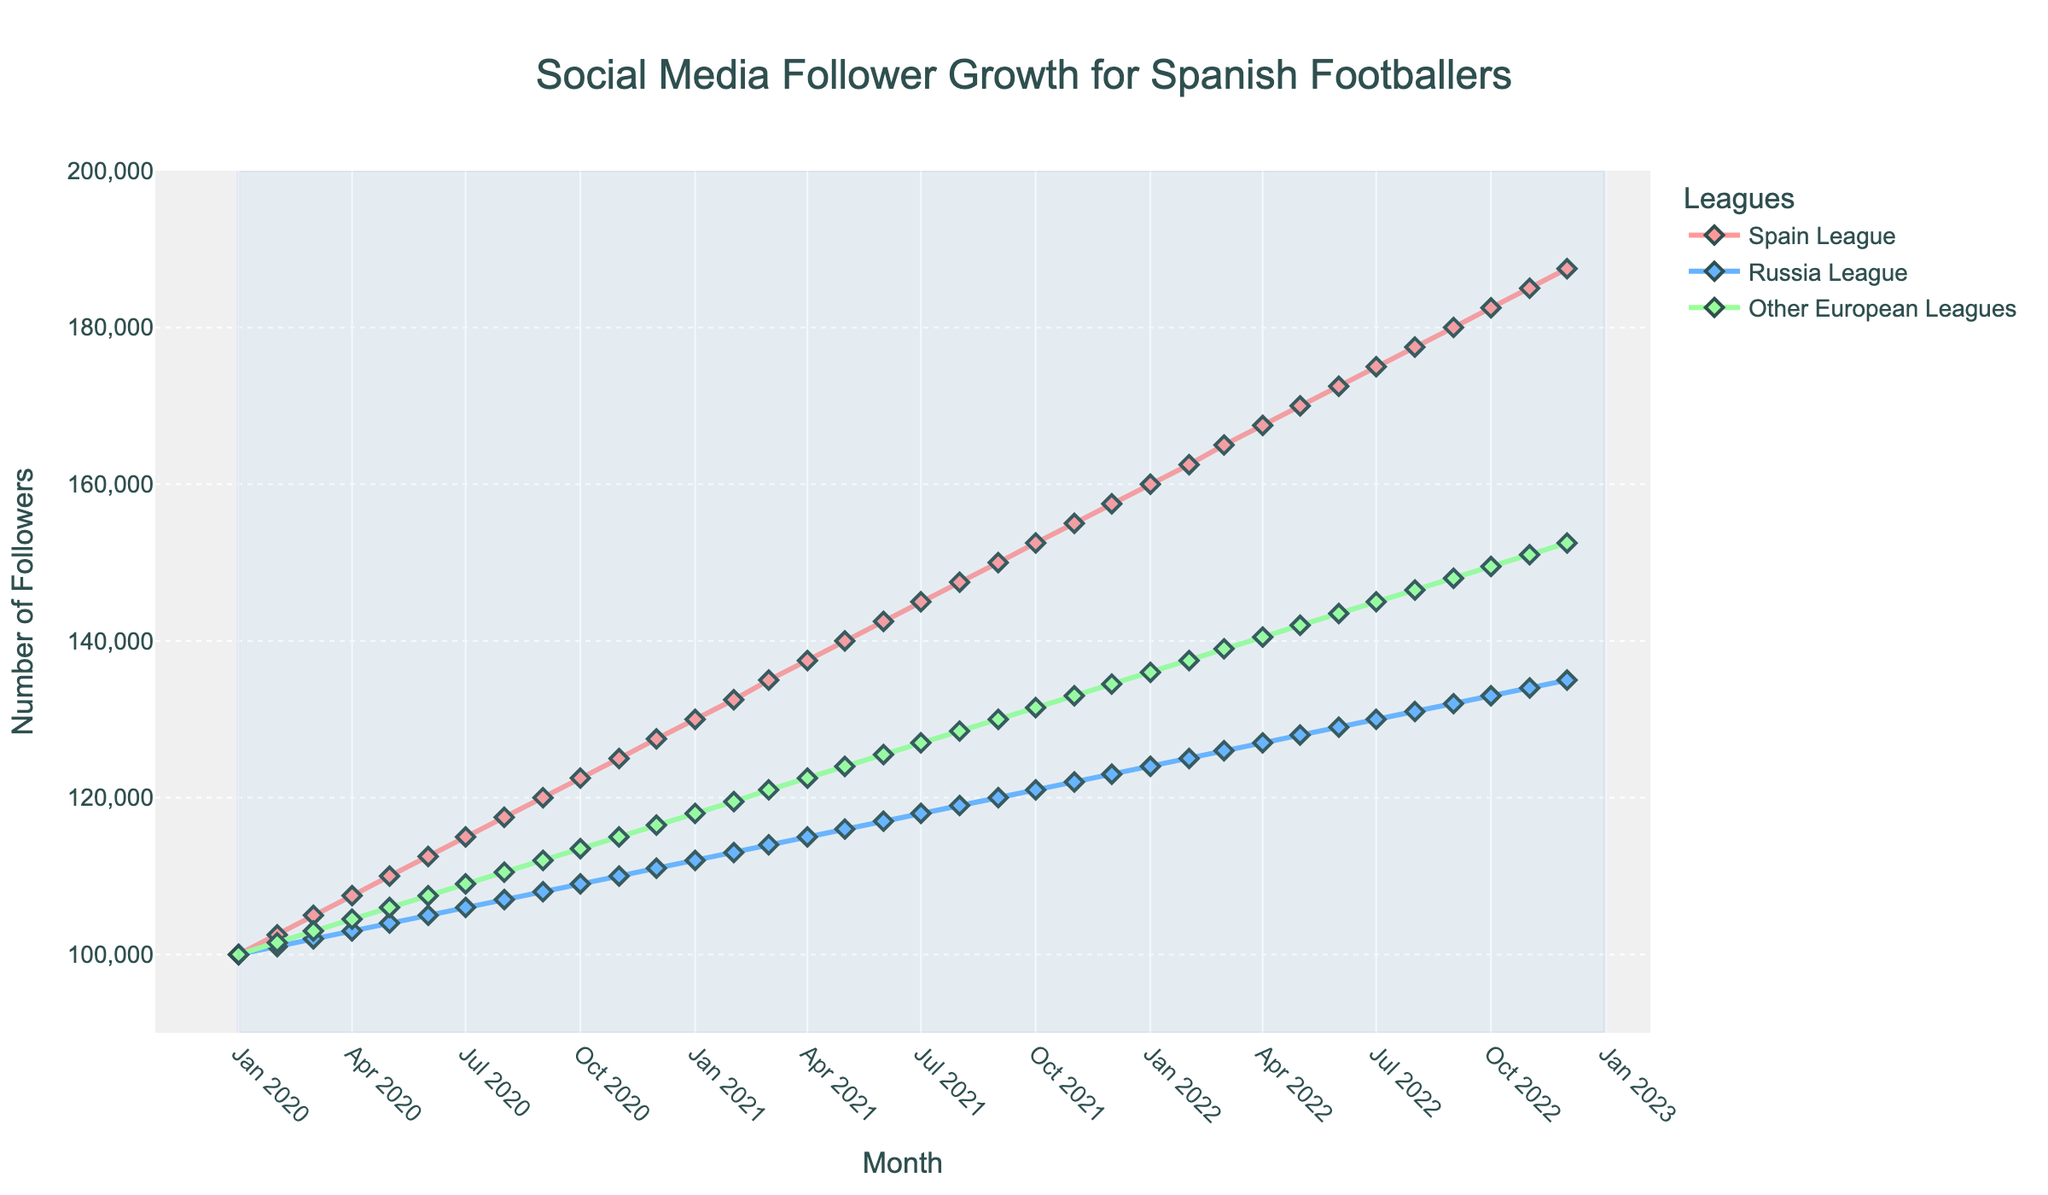How did the follower growth in the Russian League compare to the Spain League from January 2020 to December 2022? By looking at the starting and ending points for both leagues over the given period, the Spanish League started at 100,000 and grew to 187,500. The Russian League started at 100,000 and grew to 135,000. Therefore, the Spanish League had higher growth
Answer: The Spanish League had higher growth What was the approximate difference in followers between the Russian League and Other European Leagues in December 2022? In December 2022, the Russian League had around 135,000 followers and Other European Leagues had around 152,500 followers. The difference is 152,500 - 135,000 = 17,500
Answer: 17,500 Which league showed the most consistent growth over the three-year period? The Spain League showed a steady and consistent increase each month without any visible dips. This can be visually observed as the smooth slope of the Spain League line.
Answer: The Spain League What was the percentage increase in followers for the Spain League from January 2020 to December 2022? Starting followers in January 2020 were 100,000, and by December 2022, followers were 187,500. The increase is 87,500. The percentage increase is (87,500 / 100,000) * 100 = 87.5%
Answer: 87.5% During which months did the Russian League surpass 120,000 followers? Looking along the Russian League line, it surpassed 120,000 followers between August 2021 and September 2021.
Answer: August 2021 - September 2021 What is the average number of followers for the Other European Leagues in the first year (January 2020 - December 2020)? The follower numbers for each month in 2020 are: 100,000, 101,500, 103,000, 104,500, 106,000, 107,500, 109,000, 110,500, 112,000, 113,500, 115,000, 116,500. The sum is 1,299,000. The average is 1,299,000 / 12 = 108,250
Answer: 108,250 What visual element differentiates the Spain League from the other leagues on the chart? The Spain League is visually distinguished by the red color used for its line and markers.
Answer: Red color During which month did the follower count for the Russian League first equal the follower count of the Other European Leagues? By observing the lines, we can see that the Russian League and Other European Leagues were both around 100,000 followers in January 2020.
Answer: January 2020 Which league had the smallest growth in follower count and what was the total increase in that league? The Russian League had the smallest growth. It grew from 100,000 followers in January 2020 to 135,000 in December 2022, a total increase of 35,000.
Answer: Russian League; 35,000 What is the trend in the percentage of growth for the Spanish League over the entire period? The Spanish League showed a constant monthly growth, visually evident by the steadily rising line. The percentage of growth remained relatively steady as each month showed similar increments in followers.
Answer: Consistent incremental growth 